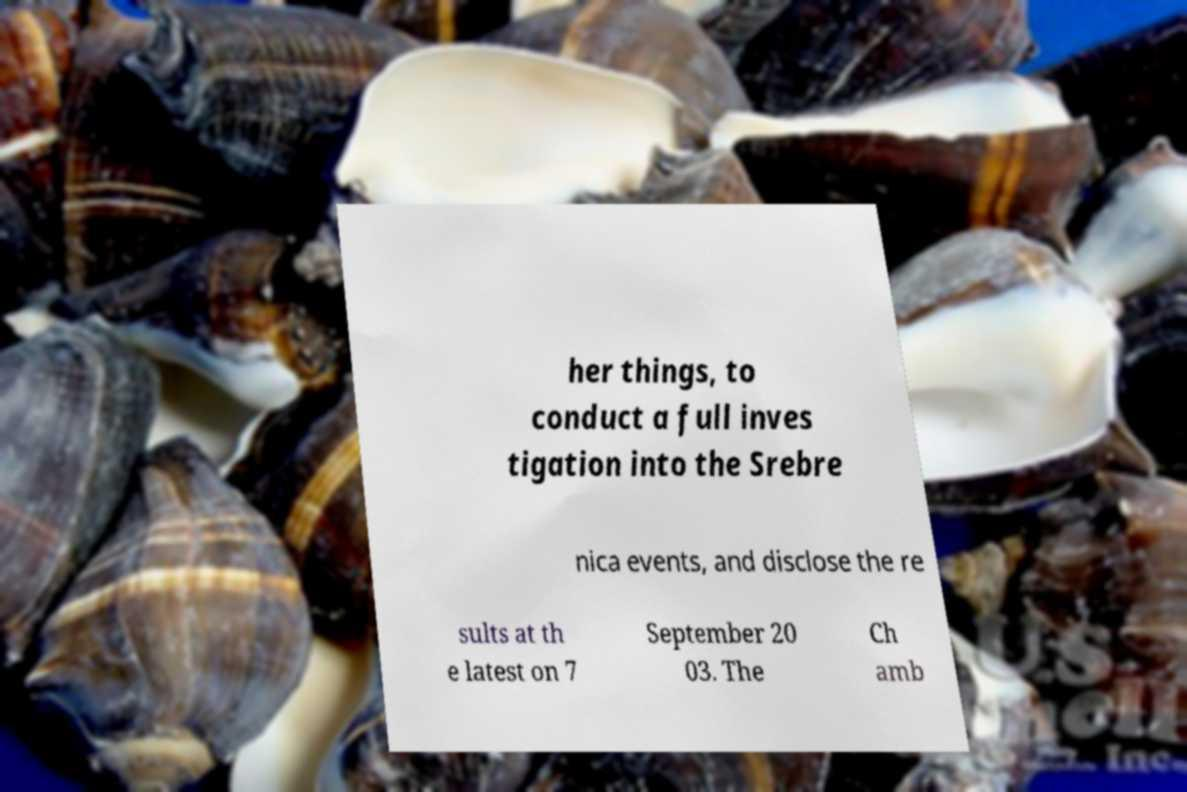Could you extract and type out the text from this image? her things, to conduct a full inves tigation into the Srebre nica events, and disclose the re sults at th e latest on 7 September 20 03. The Ch amb 